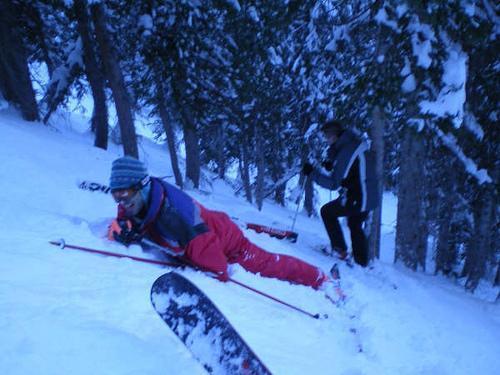How many people are in the picture?
Give a very brief answer. 2. 